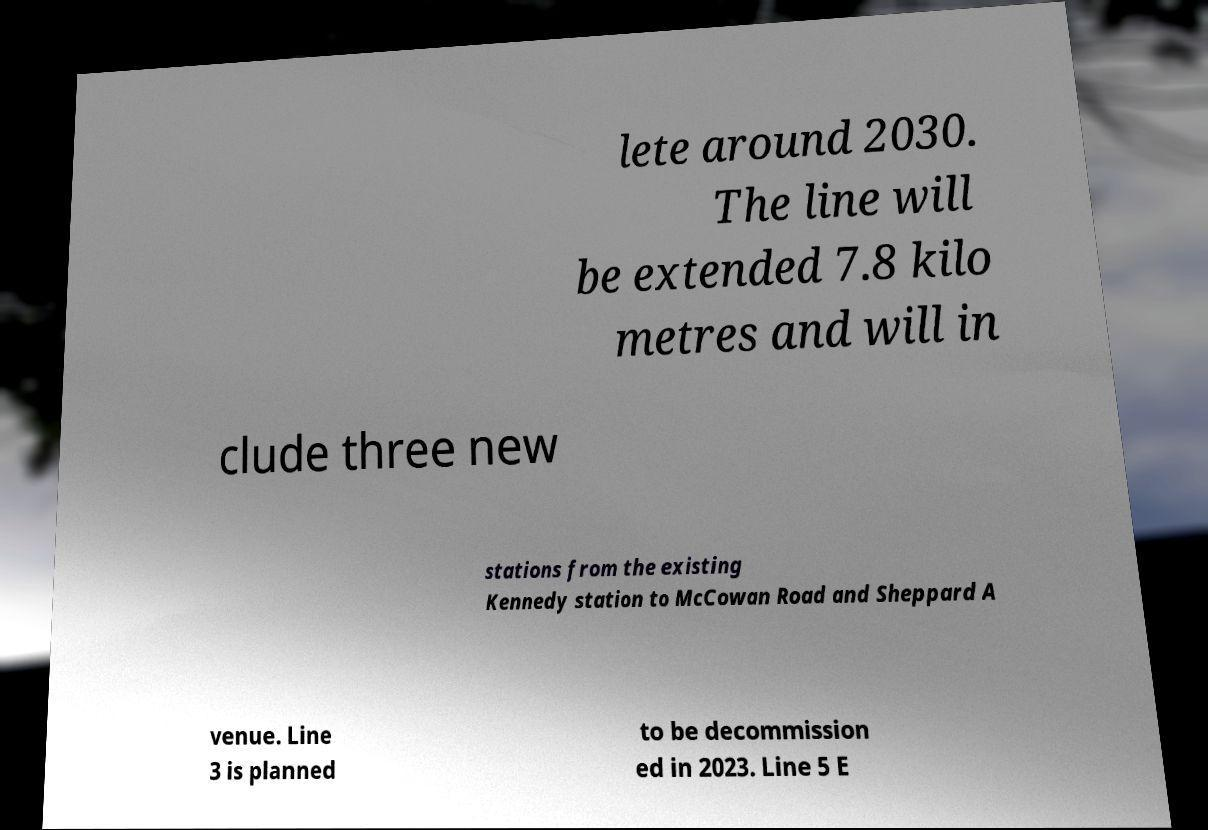Please identify and transcribe the text found in this image. lete around 2030. The line will be extended 7.8 kilo metres and will in clude three new stations from the existing Kennedy station to McCowan Road and Sheppard A venue. Line 3 is planned to be decommission ed in 2023. Line 5 E 